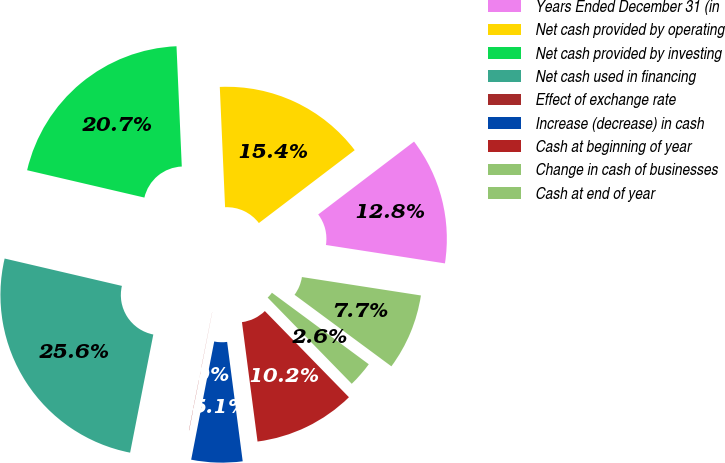Convert chart. <chart><loc_0><loc_0><loc_500><loc_500><pie_chart><fcel>Years Ended December 31 (in<fcel>Net cash provided by operating<fcel>Net cash provided by investing<fcel>Net cash used in financing<fcel>Effect of exchange rate<fcel>Increase (decrease) in cash<fcel>Cash at beginning of year<fcel>Change in cash of businesses<fcel>Cash at end of year<nl><fcel>12.79%<fcel>15.35%<fcel>20.65%<fcel>25.56%<fcel>0.02%<fcel>5.13%<fcel>10.24%<fcel>2.57%<fcel>7.68%<nl></chart> 